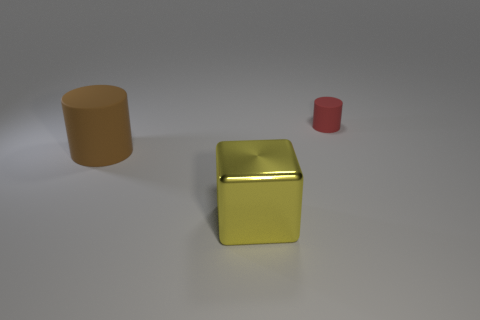Add 1 large gray rubber cylinders. How many objects exist? 4 Subtract all cylinders. How many objects are left? 1 Add 3 cylinders. How many cylinders exist? 5 Subtract 0 gray balls. How many objects are left? 3 Subtract all large brown things. Subtract all large green metal spheres. How many objects are left? 2 Add 3 big yellow cubes. How many big yellow cubes are left? 4 